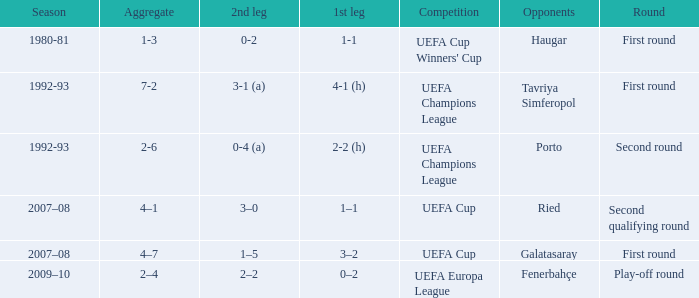 what's the competition where 1st leg is 4-1 (h) UEFA Champions League. 